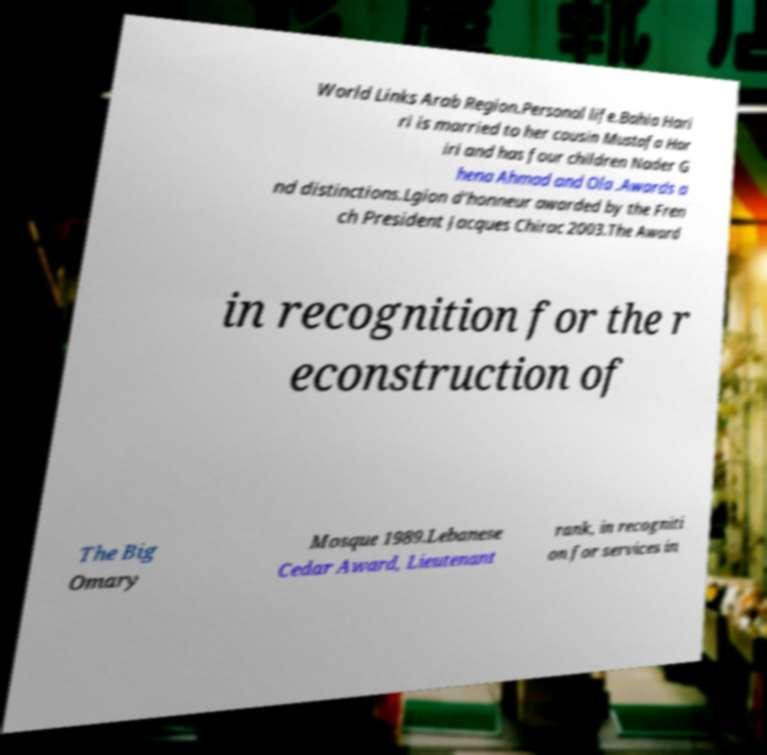What messages or text are displayed in this image? I need them in a readable, typed format. World Links Arab Region.Personal life.Bahia Hari ri is married to her cousin Mustafa Har iri and has four children Nader G hena Ahmad and Ola .Awards a nd distinctions.Lgion d'honneur awarded by the Fren ch President Jacques Chirac 2003.The Award in recognition for the r econstruction of The Big Omary Mosque 1989.Lebanese Cedar Award, Lieutenant rank, in recogniti on for services in 